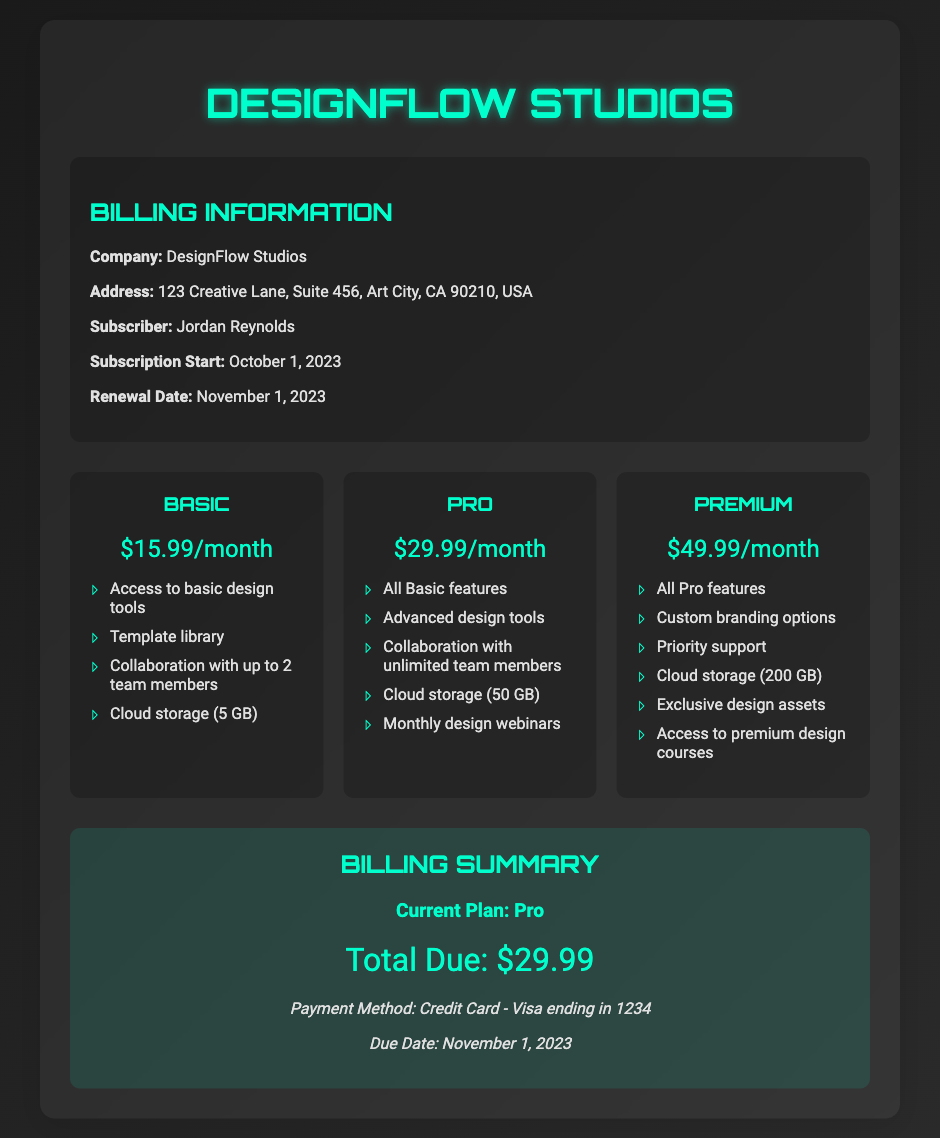What is the name of the subscriber? The name of the subscriber is clearly listed in the billing information.
Answer: Jordan Reynolds What is the renewal date? The renewal date can be found in the billing information section of the document.
Answer: November 1, 2023 What is included in the Premium tier? This requires looking at the features outlined under the Premium tier specifically.
Answer: All Pro features, Custom branding options, Priority support, Cloud storage (200 GB), Exclusive design assets, Access to premium design courses How much is the Basic subscription? The price for the Basic subscription is stated in the pricing tiers section.
Answer: $15.99/month What type of payment method is used? The payment method is mentioned in the billing summary at the end of the document.
Answer: Credit Card - Visa ending in 1234 What is the total due amount? The total due is presented clearly in the billing summary section.
Answer: $29.99 How much cloud storage is offered in the Pro plan? The amount of cloud storage for the Pro plan can be found in its feature list.
Answer: 50 GB Which tier offers collaboration with unlimited team members? This tier information requires comparing the collaboration features listed under each subscription tier.
Answer: Pro 